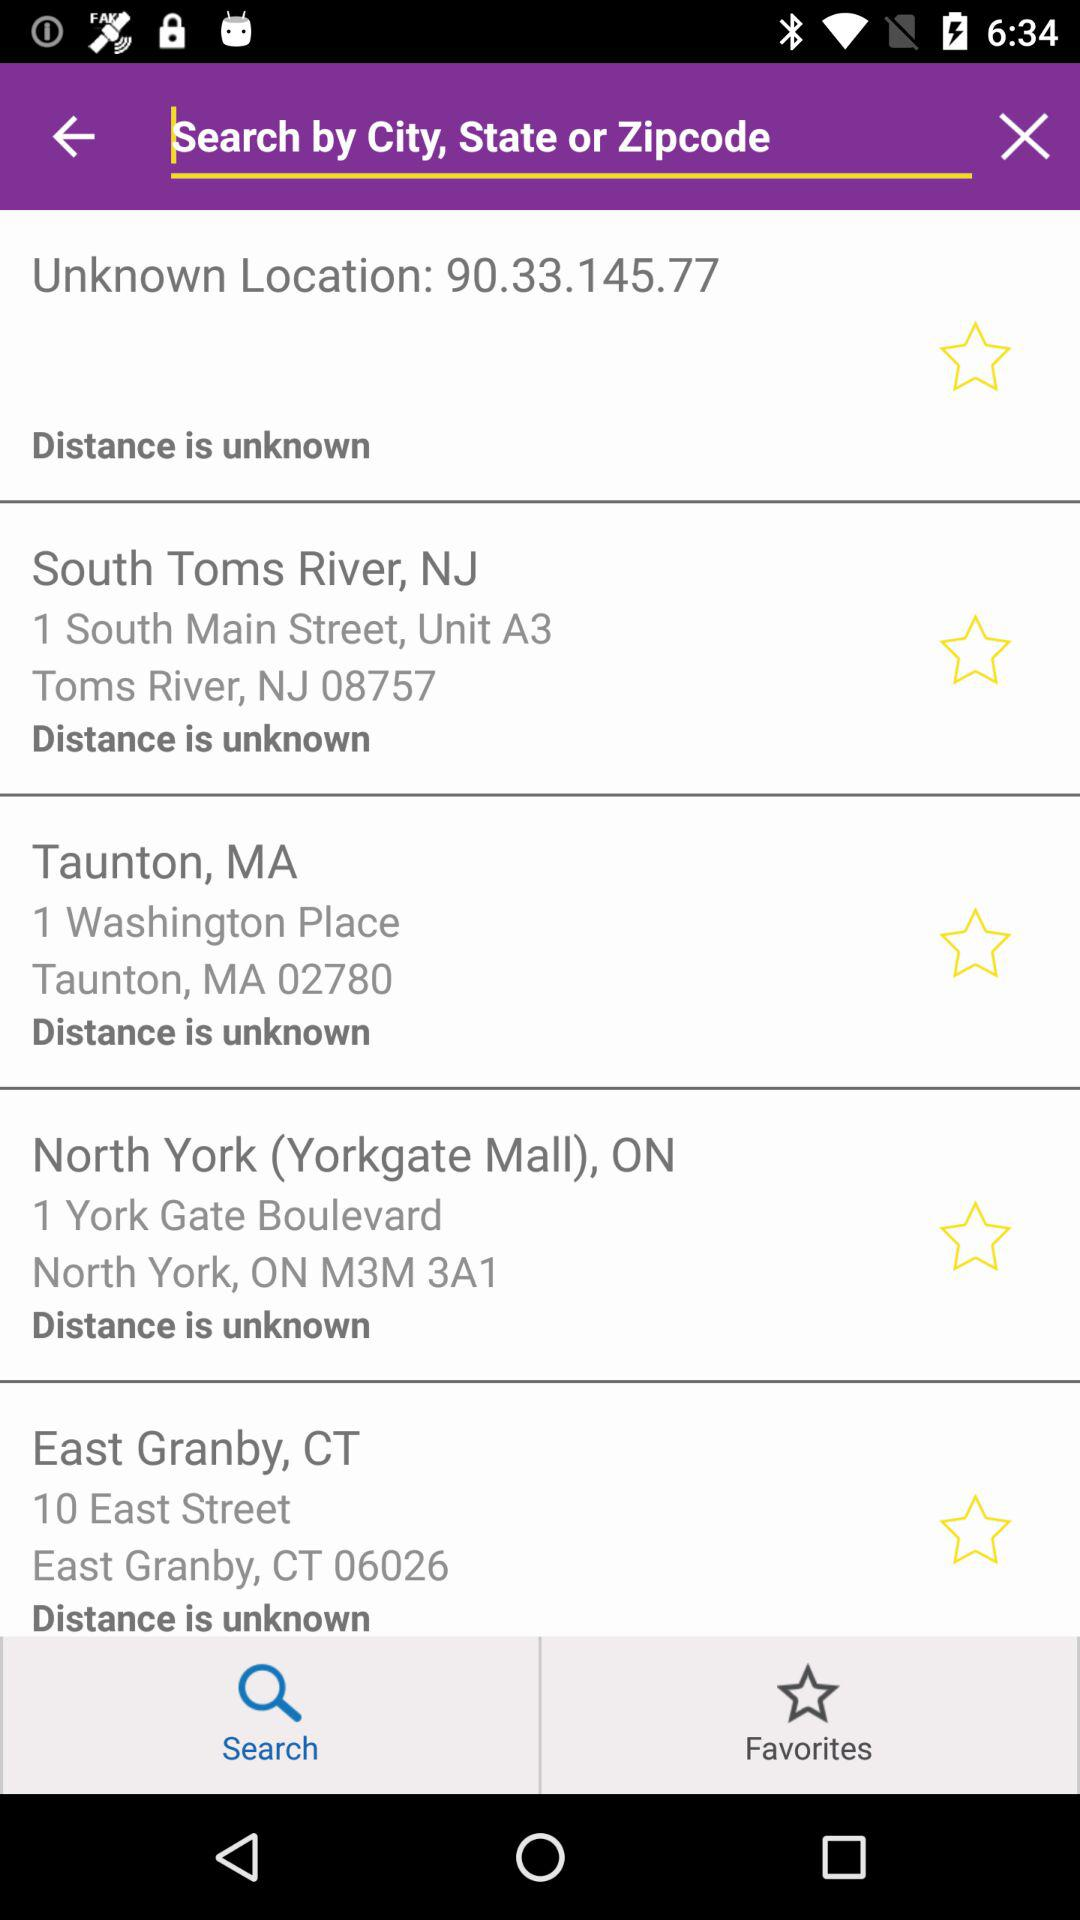What is the zip code of CT? The zip code of CT is 06026. 